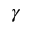Convert formula to latex. <formula><loc_0><loc_0><loc_500><loc_500>\gamma</formula> 